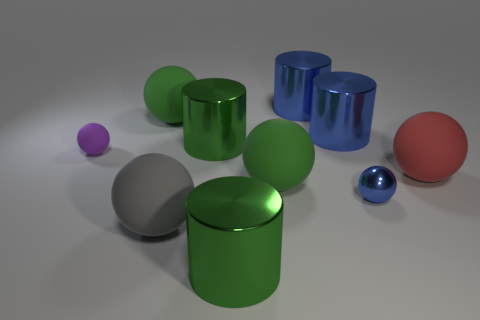Does the small rubber ball have the same color as the matte sphere to the right of the tiny metal object?
Offer a very short reply. No. Are there any large green objects that have the same shape as the tiny purple object?
Your answer should be very brief. Yes. What number of objects are green matte things or green things in front of the purple ball?
Provide a short and direct response. 3. What number of other things are there of the same material as the purple thing
Offer a terse response. 4. How many objects are either large metal objects or small matte objects?
Keep it short and to the point. 5. Is the number of tiny blue spheres to the left of the tiny rubber object greater than the number of tiny purple balls that are behind the blue metal ball?
Give a very brief answer. No. Is the color of the tiny object that is in front of the tiny purple matte thing the same as the cylinder that is in front of the red sphere?
Provide a short and direct response. No. There is a gray rubber ball to the left of the big cylinder that is in front of the large green cylinder that is behind the large red rubber sphere; what is its size?
Ensure brevity in your answer.  Large. What is the color of the other tiny object that is the same shape as the tiny purple thing?
Make the answer very short. Blue. Is the number of large red spheres to the right of the gray rubber ball greater than the number of tiny gray things?
Provide a short and direct response. Yes. 